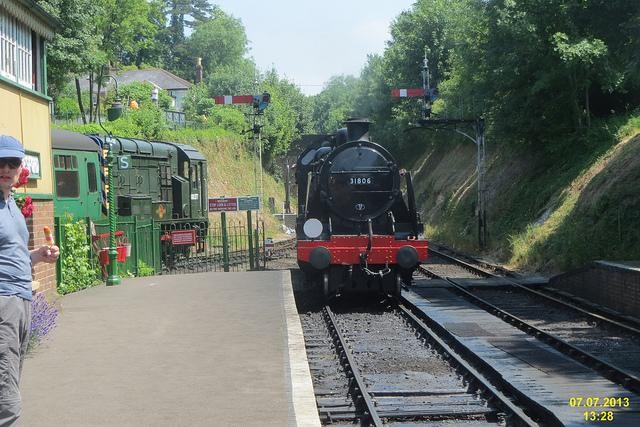What sound do people say the item on the right makes? choo choo 